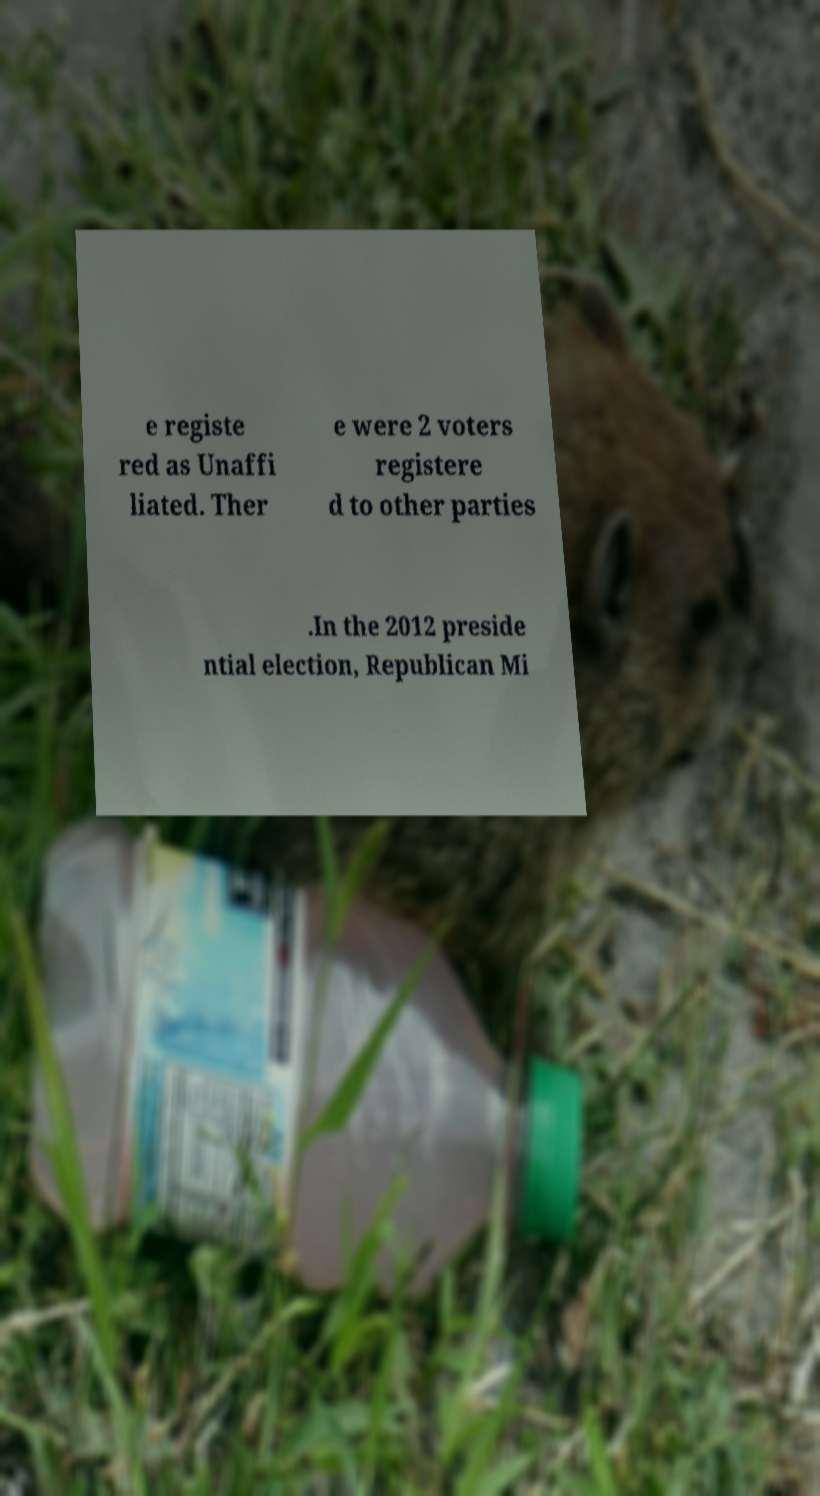Could you extract and type out the text from this image? e registe red as Unaffi liated. Ther e were 2 voters registere d to other parties .In the 2012 preside ntial election, Republican Mi 